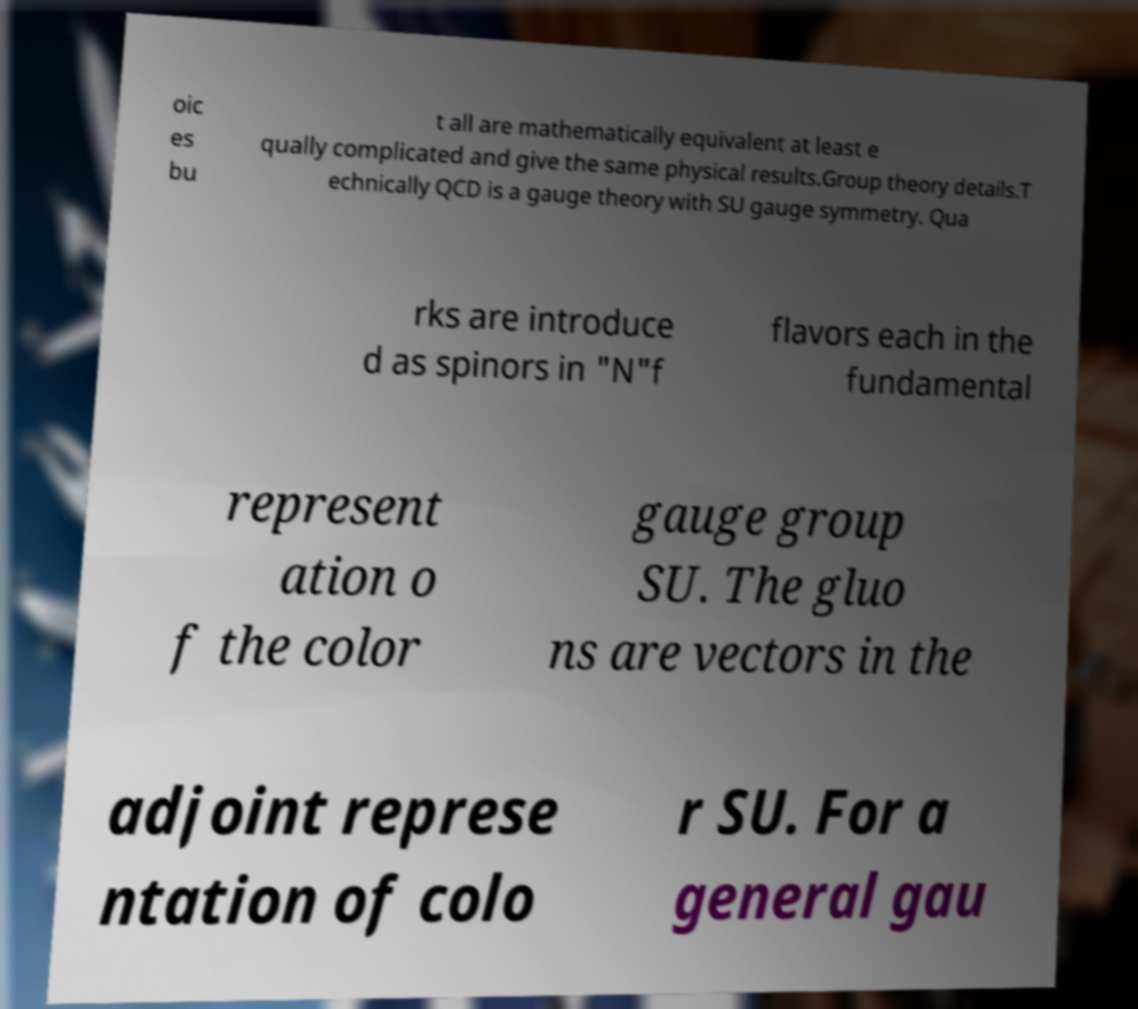For documentation purposes, I need the text within this image transcribed. Could you provide that? oic es bu t all are mathematically equivalent at least e qually complicated and give the same physical results.Group theory details.T echnically QCD is a gauge theory with SU gauge symmetry. Qua rks are introduce d as spinors in "N"f flavors each in the fundamental represent ation o f the color gauge group SU. The gluo ns are vectors in the adjoint represe ntation of colo r SU. For a general gau 